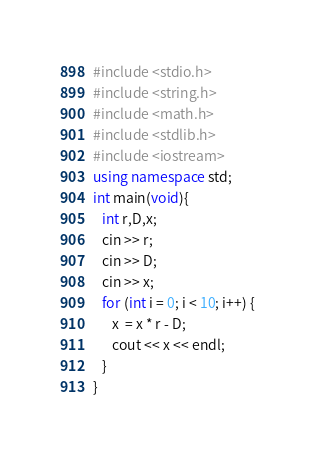Convert code to text. <code><loc_0><loc_0><loc_500><loc_500><_C++_>#include <stdio.h>
#include <string.h>
#include <math.h>
#include <stdlib.h>
#include <iostream>
using namespace std;
int main(void){
   int r,D,x;
   cin >> r;
   cin >> D;
   cin >> x;
   for (int i = 0; i < 10; i++) {
      x  = x * r - D;
      cout << x << endl;
   }
}
</code> 